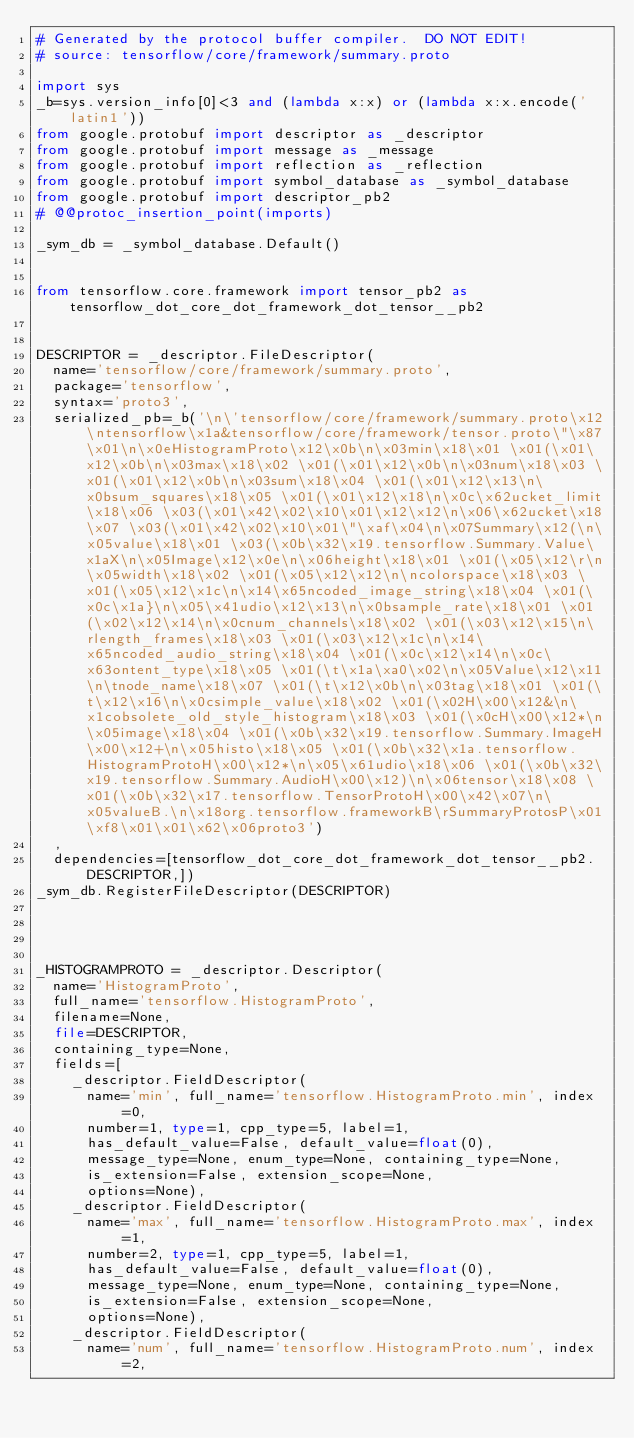<code> <loc_0><loc_0><loc_500><loc_500><_Python_># Generated by the protocol buffer compiler.  DO NOT EDIT!
# source: tensorflow/core/framework/summary.proto

import sys
_b=sys.version_info[0]<3 and (lambda x:x) or (lambda x:x.encode('latin1'))
from google.protobuf import descriptor as _descriptor
from google.protobuf import message as _message
from google.protobuf import reflection as _reflection
from google.protobuf import symbol_database as _symbol_database
from google.protobuf import descriptor_pb2
# @@protoc_insertion_point(imports)

_sym_db = _symbol_database.Default()


from tensorflow.core.framework import tensor_pb2 as tensorflow_dot_core_dot_framework_dot_tensor__pb2


DESCRIPTOR = _descriptor.FileDescriptor(
  name='tensorflow/core/framework/summary.proto',
  package='tensorflow',
  syntax='proto3',
  serialized_pb=_b('\n\'tensorflow/core/framework/summary.proto\x12\ntensorflow\x1a&tensorflow/core/framework/tensor.proto\"\x87\x01\n\x0eHistogramProto\x12\x0b\n\x03min\x18\x01 \x01(\x01\x12\x0b\n\x03max\x18\x02 \x01(\x01\x12\x0b\n\x03num\x18\x03 \x01(\x01\x12\x0b\n\x03sum\x18\x04 \x01(\x01\x12\x13\n\x0bsum_squares\x18\x05 \x01(\x01\x12\x18\n\x0c\x62ucket_limit\x18\x06 \x03(\x01\x42\x02\x10\x01\x12\x12\n\x06\x62ucket\x18\x07 \x03(\x01\x42\x02\x10\x01\"\xaf\x04\n\x07Summary\x12(\n\x05value\x18\x01 \x03(\x0b\x32\x19.tensorflow.Summary.Value\x1aX\n\x05Image\x12\x0e\n\x06height\x18\x01 \x01(\x05\x12\r\n\x05width\x18\x02 \x01(\x05\x12\x12\n\ncolorspace\x18\x03 \x01(\x05\x12\x1c\n\x14\x65ncoded_image_string\x18\x04 \x01(\x0c\x1a}\n\x05\x41udio\x12\x13\n\x0bsample_rate\x18\x01 \x01(\x02\x12\x14\n\x0cnum_channels\x18\x02 \x01(\x03\x12\x15\n\rlength_frames\x18\x03 \x01(\x03\x12\x1c\n\x14\x65ncoded_audio_string\x18\x04 \x01(\x0c\x12\x14\n\x0c\x63ontent_type\x18\x05 \x01(\t\x1a\xa0\x02\n\x05Value\x12\x11\n\tnode_name\x18\x07 \x01(\t\x12\x0b\n\x03tag\x18\x01 \x01(\t\x12\x16\n\x0csimple_value\x18\x02 \x01(\x02H\x00\x12&\n\x1cobsolete_old_style_histogram\x18\x03 \x01(\x0cH\x00\x12*\n\x05image\x18\x04 \x01(\x0b\x32\x19.tensorflow.Summary.ImageH\x00\x12+\n\x05histo\x18\x05 \x01(\x0b\x32\x1a.tensorflow.HistogramProtoH\x00\x12*\n\x05\x61udio\x18\x06 \x01(\x0b\x32\x19.tensorflow.Summary.AudioH\x00\x12)\n\x06tensor\x18\x08 \x01(\x0b\x32\x17.tensorflow.TensorProtoH\x00\x42\x07\n\x05valueB.\n\x18org.tensorflow.frameworkB\rSummaryProtosP\x01\xf8\x01\x01\x62\x06proto3')
  ,
  dependencies=[tensorflow_dot_core_dot_framework_dot_tensor__pb2.DESCRIPTOR,])
_sym_db.RegisterFileDescriptor(DESCRIPTOR)




_HISTOGRAMPROTO = _descriptor.Descriptor(
  name='HistogramProto',
  full_name='tensorflow.HistogramProto',
  filename=None,
  file=DESCRIPTOR,
  containing_type=None,
  fields=[
    _descriptor.FieldDescriptor(
      name='min', full_name='tensorflow.HistogramProto.min', index=0,
      number=1, type=1, cpp_type=5, label=1,
      has_default_value=False, default_value=float(0),
      message_type=None, enum_type=None, containing_type=None,
      is_extension=False, extension_scope=None,
      options=None),
    _descriptor.FieldDescriptor(
      name='max', full_name='tensorflow.HistogramProto.max', index=1,
      number=2, type=1, cpp_type=5, label=1,
      has_default_value=False, default_value=float(0),
      message_type=None, enum_type=None, containing_type=None,
      is_extension=False, extension_scope=None,
      options=None),
    _descriptor.FieldDescriptor(
      name='num', full_name='tensorflow.HistogramProto.num', index=2,</code> 